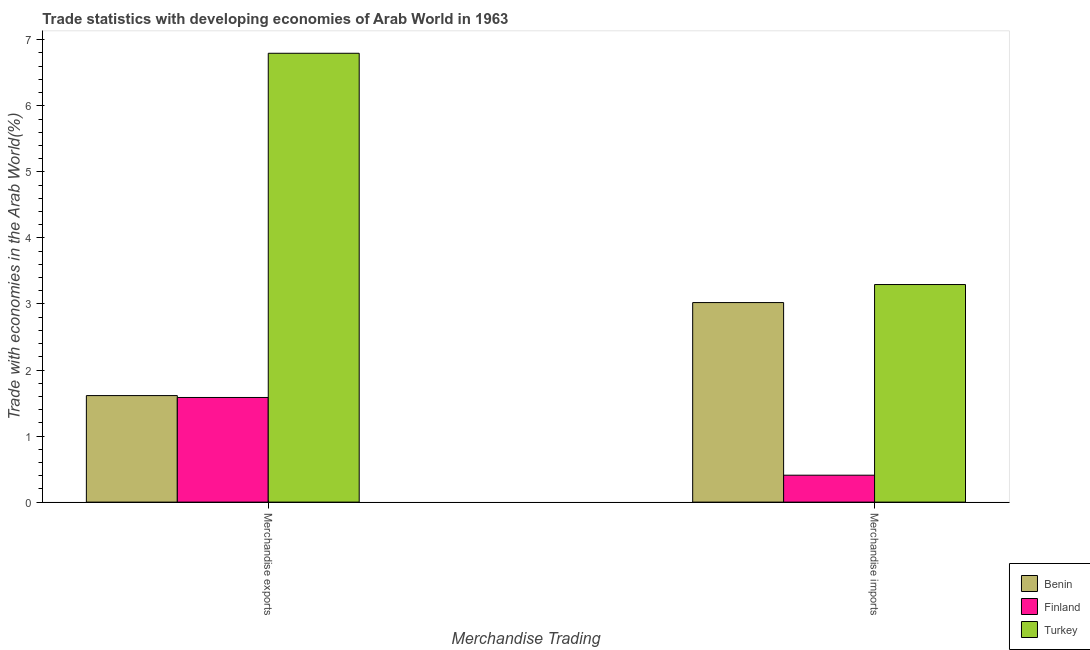Are the number of bars on each tick of the X-axis equal?
Keep it short and to the point. Yes. How many bars are there on the 2nd tick from the left?
Your answer should be very brief. 3. What is the merchandise imports in Finland?
Your answer should be very brief. 0.41. Across all countries, what is the maximum merchandise imports?
Give a very brief answer. 3.29. Across all countries, what is the minimum merchandise imports?
Ensure brevity in your answer.  0.41. In which country was the merchandise imports maximum?
Give a very brief answer. Turkey. In which country was the merchandise imports minimum?
Your response must be concise. Finland. What is the total merchandise imports in the graph?
Offer a terse response. 6.72. What is the difference between the merchandise exports in Turkey and that in Benin?
Offer a very short reply. 5.18. What is the difference between the merchandise exports in Finland and the merchandise imports in Benin?
Offer a very short reply. -1.44. What is the average merchandise imports per country?
Your response must be concise. 2.24. What is the difference between the merchandise exports and merchandise imports in Finland?
Make the answer very short. 1.18. What is the ratio of the merchandise imports in Turkey to that in Benin?
Your answer should be very brief. 1.09. Is the merchandise imports in Finland less than that in Benin?
Provide a succinct answer. Yes. In how many countries, is the merchandise exports greater than the average merchandise exports taken over all countries?
Ensure brevity in your answer.  1. What does the 1st bar from the left in Merchandise imports represents?
Provide a short and direct response. Benin. What does the 2nd bar from the right in Merchandise exports represents?
Give a very brief answer. Finland. How many bars are there?
Give a very brief answer. 6. Are all the bars in the graph horizontal?
Your answer should be very brief. No. How many countries are there in the graph?
Offer a terse response. 3. Does the graph contain any zero values?
Keep it short and to the point. No. Does the graph contain grids?
Give a very brief answer. No. How are the legend labels stacked?
Your answer should be very brief. Vertical. What is the title of the graph?
Provide a succinct answer. Trade statistics with developing economies of Arab World in 1963. What is the label or title of the X-axis?
Give a very brief answer. Merchandise Trading. What is the label or title of the Y-axis?
Keep it short and to the point. Trade with economies in the Arab World(%). What is the Trade with economies in the Arab World(%) in Benin in Merchandise exports?
Ensure brevity in your answer.  1.61. What is the Trade with economies in the Arab World(%) of Finland in Merchandise exports?
Give a very brief answer. 1.58. What is the Trade with economies in the Arab World(%) in Turkey in Merchandise exports?
Keep it short and to the point. 6.8. What is the Trade with economies in the Arab World(%) of Benin in Merchandise imports?
Ensure brevity in your answer.  3.02. What is the Trade with economies in the Arab World(%) of Finland in Merchandise imports?
Give a very brief answer. 0.41. What is the Trade with economies in the Arab World(%) in Turkey in Merchandise imports?
Keep it short and to the point. 3.29. Across all Merchandise Trading, what is the maximum Trade with economies in the Arab World(%) of Benin?
Provide a short and direct response. 3.02. Across all Merchandise Trading, what is the maximum Trade with economies in the Arab World(%) in Finland?
Your response must be concise. 1.58. Across all Merchandise Trading, what is the maximum Trade with economies in the Arab World(%) in Turkey?
Keep it short and to the point. 6.8. Across all Merchandise Trading, what is the minimum Trade with economies in the Arab World(%) of Benin?
Offer a very short reply. 1.61. Across all Merchandise Trading, what is the minimum Trade with economies in the Arab World(%) of Finland?
Your answer should be compact. 0.41. Across all Merchandise Trading, what is the minimum Trade with economies in the Arab World(%) in Turkey?
Ensure brevity in your answer.  3.29. What is the total Trade with economies in the Arab World(%) in Benin in the graph?
Your response must be concise. 4.63. What is the total Trade with economies in the Arab World(%) of Finland in the graph?
Make the answer very short. 1.99. What is the total Trade with economies in the Arab World(%) in Turkey in the graph?
Provide a short and direct response. 10.09. What is the difference between the Trade with economies in the Arab World(%) of Benin in Merchandise exports and that in Merchandise imports?
Offer a terse response. -1.41. What is the difference between the Trade with economies in the Arab World(%) of Finland in Merchandise exports and that in Merchandise imports?
Your answer should be very brief. 1.18. What is the difference between the Trade with economies in the Arab World(%) in Turkey in Merchandise exports and that in Merchandise imports?
Make the answer very short. 3.5. What is the difference between the Trade with economies in the Arab World(%) of Benin in Merchandise exports and the Trade with economies in the Arab World(%) of Finland in Merchandise imports?
Your answer should be compact. 1.21. What is the difference between the Trade with economies in the Arab World(%) in Benin in Merchandise exports and the Trade with economies in the Arab World(%) in Turkey in Merchandise imports?
Offer a terse response. -1.68. What is the difference between the Trade with economies in the Arab World(%) of Finland in Merchandise exports and the Trade with economies in the Arab World(%) of Turkey in Merchandise imports?
Offer a very short reply. -1.71. What is the average Trade with economies in the Arab World(%) of Benin per Merchandise Trading?
Offer a very short reply. 2.32. What is the average Trade with economies in the Arab World(%) of Finland per Merchandise Trading?
Provide a succinct answer. 1. What is the average Trade with economies in the Arab World(%) of Turkey per Merchandise Trading?
Keep it short and to the point. 5.04. What is the difference between the Trade with economies in the Arab World(%) in Benin and Trade with economies in the Arab World(%) in Finland in Merchandise exports?
Provide a short and direct response. 0.03. What is the difference between the Trade with economies in the Arab World(%) in Benin and Trade with economies in the Arab World(%) in Turkey in Merchandise exports?
Ensure brevity in your answer.  -5.18. What is the difference between the Trade with economies in the Arab World(%) in Finland and Trade with economies in the Arab World(%) in Turkey in Merchandise exports?
Ensure brevity in your answer.  -5.21. What is the difference between the Trade with economies in the Arab World(%) of Benin and Trade with economies in the Arab World(%) of Finland in Merchandise imports?
Ensure brevity in your answer.  2.61. What is the difference between the Trade with economies in the Arab World(%) of Benin and Trade with economies in the Arab World(%) of Turkey in Merchandise imports?
Ensure brevity in your answer.  -0.27. What is the difference between the Trade with economies in the Arab World(%) of Finland and Trade with economies in the Arab World(%) of Turkey in Merchandise imports?
Your answer should be compact. -2.89. What is the ratio of the Trade with economies in the Arab World(%) in Benin in Merchandise exports to that in Merchandise imports?
Keep it short and to the point. 0.53. What is the ratio of the Trade with economies in the Arab World(%) in Finland in Merchandise exports to that in Merchandise imports?
Offer a terse response. 3.89. What is the ratio of the Trade with economies in the Arab World(%) of Turkey in Merchandise exports to that in Merchandise imports?
Offer a terse response. 2.06. What is the difference between the highest and the second highest Trade with economies in the Arab World(%) in Benin?
Your response must be concise. 1.41. What is the difference between the highest and the second highest Trade with economies in the Arab World(%) in Finland?
Your answer should be very brief. 1.18. What is the difference between the highest and the second highest Trade with economies in the Arab World(%) of Turkey?
Make the answer very short. 3.5. What is the difference between the highest and the lowest Trade with economies in the Arab World(%) in Benin?
Provide a succinct answer. 1.41. What is the difference between the highest and the lowest Trade with economies in the Arab World(%) in Finland?
Ensure brevity in your answer.  1.18. What is the difference between the highest and the lowest Trade with economies in the Arab World(%) of Turkey?
Ensure brevity in your answer.  3.5. 